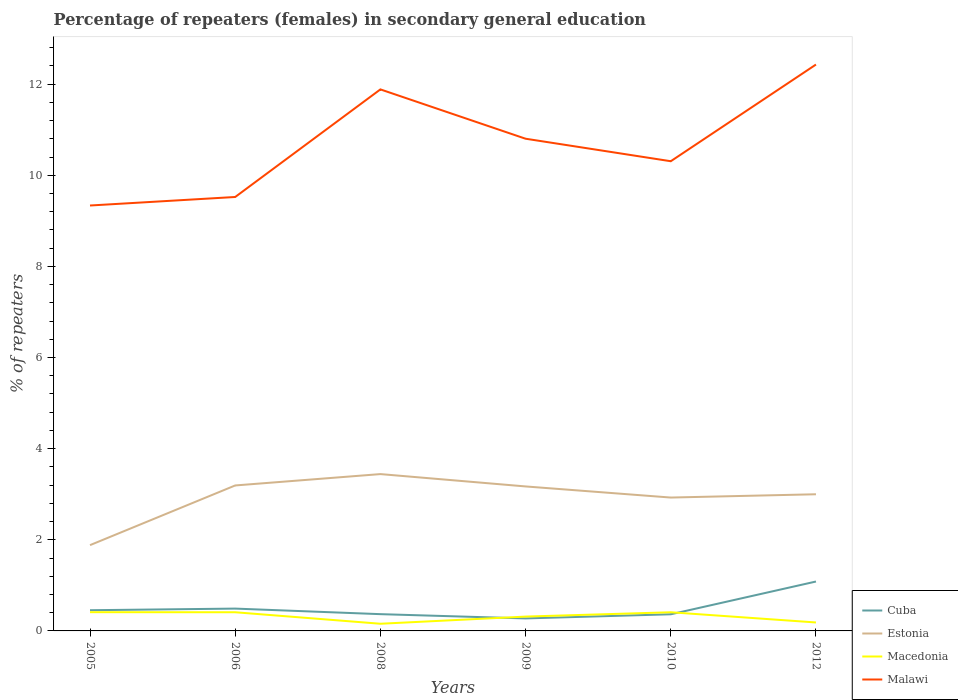Across all years, what is the maximum percentage of female repeaters in Cuba?
Keep it short and to the point. 0.27. What is the total percentage of female repeaters in Malawi in the graph?
Your answer should be very brief. -0.97. What is the difference between the highest and the second highest percentage of female repeaters in Malawi?
Your answer should be compact. 3.09. How many lines are there?
Offer a terse response. 4. Does the graph contain any zero values?
Give a very brief answer. No. Does the graph contain grids?
Offer a terse response. No. Where does the legend appear in the graph?
Give a very brief answer. Bottom right. How are the legend labels stacked?
Keep it short and to the point. Vertical. What is the title of the graph?
Your response must be concise. Percentage of repeaters (females) in secondary general education. What is the label or title of the X-axis?
Make the answer very short. Years. What is the label or title of the Y-axis?
Provide a succinct answer. % of repeaters. What is the % of repeaters in Cuba in 2005?
Offer a very short reply. 0.45. What is the % of repeaters of Estonia in 2005?
Provide a short and direct response. 1.88. What is the % of repeaters of Macedonia in 2005?
Provide a succinct answer. 0.41. What is the % of repeaters of Malawi in 2005?
Offer a very short reply. 9.34. What is the % of repeaters of Cuba in 2006?
Make the answer very short. 0.49. What is the % of repeaters of Estonia in 2006?
Your answer should be compact. 3.19. What is the % of repeaters of Macedonia in 2006?
Make the answer very short. 0.41. What is the % of repeaters in Malawi in 2006?
Offer a very short reply. 9.52. What is the % of repeaters in Cuba in 2008?
Keep it short and to the point. 0.37. What is the % of repeaters of Estonia in 2008?
Your response must be concise. 3.44. What is the % of repeaters of Macedonia in 2008?
Provide a short and direct response. 0.16. What is the % of repeaters of Malawi in 2008?
Your answer should be very brief. 11.88. What is the % of repeaters of Cuba in 2009?
Provide a succinct answer. 0.27. What is the % of repeaters in Estonia in 2009?
Keep it short and to the point. 3.17. What is the % of repeaters in Macedonia in 2009?
Your answer should be very brief. 0.31. What is the % of repeaters of Malawi in 2009?
Provide a short and direct response. 10.8. What is the % of repeaters in Cuba in 2010?
Your answer should be very brief. 0.37. What is the % of repeaters of Estonia in 2010?
Offer a very short reply. 2.93. What is the % of repeaters in Macedonia in 2010?
Keep it short and to the point. 0.41. What is the % of repeaters in Malawi in 2010?
Give a very brief answer. 10.31. What is the % of repeaters of Cuba in 2012?
Offer a very short reply. 1.08. What is the % of repeaters of Estonia in 2012?
Provide a succinct answer. 3. What is the % of repeaters of Macedonia in 2012?
Your response must be concise. 0.19. What is the % of repeaters in Malawi in 2012?
Ensure brevity in your answer.  12.43. Across all years, what is the maximum % of repeaters of Cuba?
Your answer should be compact. 1.08. Across all years, what is the maximum % of repeaters of Estonia?
Your response must be concise. 3.44. Across all years, what is the maximum % of repeaters of Macedonia?
Your answer should be very brief. 0.41. Across all years, what is the maximum % of repeaters of Malawi?
Provide a succinct answer. 12.43. Across all years, what is the minimum % of repeaters of Cuba?
Your answer should be compact. 0.27. Across all years, what is the minimum % of repeaters in Estonia?
Ensure brevity in your answer.  1.88. Across all years, what is the minimum % of repeaters of Macedonia?
Offer a terse response. 0.16. Across all years, what is the minimum % of repeaters of Malawi?
Your answer should be very brief. 9.34. What is the total % of repeaters of Cuba in the graph?
Make the answer very short. 3.04. What is the total % of repeaters of Estonia in the graph?
Keep it short and to the point. 17.61. What is the total % of repeaters of Macedonia in the graph?
Your answer should be compact. 1.89. What is the total % of repeaters of Malawi in the graph?
Offer a terse response. 64.28. What is the difference between the % of repeaters of Cuba in 2005 and that in 2006?
Your answer should be compact. -0.04. What is the difference between the % of repeaters in Estonia in 2005 and that in 2006?
Your response must be concise. -1.31. What is the difference between the % of repeaters in Macedonia in 2005 and that in 2006?
Ensure brevity in your answer.  0. What is the difference between the % of repeaters of Malawi in 2005 and that in 2006?
Make the answer very short. -0.19. What is the difference between the % of repeaters in Cuba in 2005 and that in 2008?
Offer a terse response. 0.09. What is the difference between the % of repeaters in Estonia in 2005 and that in 2008?
Make the answer very short. -1.56. What is the difference between the % of repeaters of Macedonia in 2005 and that in 2008?
Give a very brief answer. 0.25. What is the difference between the % of repeaters in Malawi in 2005 and that in 2008?
Provide a short and direct response. -2.55. What is the difference between the % of repeaters in Cuba in 2005 and that in 2009?
Make the answer very short. 0.18. What is the difference between the % of repeaters of Estonia in 2005 and that in 2009?
Your answer should be very brief. -1.29. What is the difference between the % of repeaters of Macedonia in 2005 and that in 2009?
Make the answer very short. 0.1. What is the difference between the % of repeaters of Malawi in 2005 and that in 2009?
Your answer should be very brief. -1.47. What is the difference between the % of repeaters in Cuba in 2005 and that in 2010?
Offer a very short reply. 0.09. What is the difference between the % of repeaters in Estonia in 2005 and that in 2010?
Your answer should be very brief. -1.04. What is the difference between the % of repeaters of Macedonia in 2005 and that in 2010?
Your answer should be very brief. 0. What is the difference between the % of repeaters in Malawi in 2005 and that in 2010?
Keep it short and to the point. -0.97. What is the difference between the % of repeaters of Cuba in 2005 and that in 2012?
Provide a short and direct response. -0.63. What is the difference between the % of repeaters of Estonia in 2005 and that in 2012?
Your answer should be compact. -1.12. What is the difference between the % of repeaters in Macedonia in 2005 and that in 2012?
Make the answer very short. 0.23. What is the difference between the % of repeaters of Malawi in 2005 and that in 2012?
Offer a very short reply. -3.09. What is the difference between the % of repeaters of Cuba in 2006 and that in 2008?
Offer a very short reply. 0.12. What is the difference between the % of repeaters in Estonia in 2006 and that in 2008?
Offer a terse response. -0.25. What is the difference between the % of repeaters in Macedonia in 2006 and that in 2008?
Offer a terse response. 0.25. What is the difference between the % of repeaters of Malawi in 2006 and that in 2008?
Ensure brevity in your answer.  -2.36. What is the difference between the % of repeaters of Cuba in 2006 and that in 2009?
Offer a terse response. 0.22. What is the difference between the % of repeaters of Estonia in 2006 and that in 2009?
Keep it short and to the point. 0.02. What is the difference between the % of repeaters in Macedonia in 2006 and that in 2009?
Offer a terse response. 0.1. What is the difference between the % of repeaters in Malawi in 2006 and that in 2009?
Ensure brevity in your answer.  -1.28. What is the difference between the % of repeaters of Cuba in 2006 and that in 2010?
Offer a terse response. 0.12. What is the difference between the % of repeaters in Estonia in 2006 and that in 2010?
Your answer should be very brief. 0.27. What is the difference between the % of repeaters of Malawi in 2006 and that in 2010?
Offer a very short reply. -0.78. What is the difference between the % of repeaters of Cuba in 2006 and that in 2012?
Give a very brief answer. -0.59. What is the difference between the % of repeaters in Estonia in 2006 and that in 2012?
Keep it short and to the point. 0.19. What is the difference between the % of repeaters of Macedonia in 2006 and that in 2012?
Provide a succinct answer. 0.22. What is the difference between the % of repeaters in Malawi in 2006 and that in 2012?
Your answer should be compact. -2.91. What is the difference between the % of repeaters in Cuba in 2008 and that in 2009?
Offer a very short reply. 0.09. What is the difference between the % of repeaters in Estonia in 2008 and that in 2009?
Your response must be concise. 0.27. What is the difference between the % of repeaters in Macedonia in 2008 and that in 2009?
Offer a terse response. -0.16. What is the difference between the % of repeaters in Malawi in 2008 and that in 2009?
Keep it short and to the point. 1.08. What is the difference between the % of repeaters in Cuba in 2008 and that in 2010?
Provide a short and direct response. 0. What is the difference between the % of repeaters of Estonia in 2008 and that in 2010?
Your response must be concise. 0.51. What is the difference between the % of repeaters of Macedonia in 2008 and that in 2010?
Your response must be concise. -0.25. What is the difference between the % of repeaters of Malawi in 2008 and that in 2010?
Give a very brief answer. 1.58. What is the difference between the % of repeaters of Cuba in 2008 and that in 2012?
Your answer should be very brief. -0.72. What is the difference between the % of repeaters in Estonia in 2008 and that in 2012?
Offer a very short reply. 0.44. What is the difference between the % of repeaters of Macedonia in 2008 and that in 2012?
Provide a short and direct response. -0.03. What is the difference between the % of repeaters in Malawi in 2008 and that in 2012?
Ensure brevity in your answer.  -0.55. What is the difference between the % of repeaters of Cuba in 2009 and that in 2010?
Your answer should be compact. -0.09. What is the difference between the % of repeaters of Estonia in 2009 and that in 2010?
Provide a succinct answer. 0.24. What is the difference between the % of repeaters in Macedonia in 2009 and that in 2010?
Your answer should be compact. -0.1. What is the difference between the % of repeaters of Malawi in 2009 and that in 2010?
Ensure brevity in your answer.  0.49. What is the difference between the % of repeaters of Cuba in 2009 and that in 2012?
Offer a terse response. -0.81. What is the difference between the % of repeaters of Estonia in 2009 and that in 2012?
Provide a short and direct response. 0.17. What is the difference between the % of repeaters in Macedonia in 2009 and that in 2012?
Your answer should be very brief. 0.13. What is the difference between the % of repeaters in Malawi in 2009 and that in 2012?
Give a very brief answer. -1.63. What is the difference between the % of repeaters of Cuba in 2010 and that in 2012?
Give a very brief answer. -0.72. What is the difference between the % of repeaters in Estonia in 2010 and that in 2012?
Provide a short and direct response. -0.07. What is the difference between the % of repeaters of Macedonia in 2010 and that in 2012?
Provide a short and direct response. 0.22. What is the difference between the % of repeaters of Malawi in 2010 and that in 2012?
Offer a very short reply. -2.12. What is the difference between the % of repeaters of Cuba in 2005 and the % of repeaters of Estonia in 2006?
Ensure brevity in your answer.  -2.74. What is the difference between the % of repeaters of Cuba in 2005 and the % of repeaters of Macedonia in 2006?
Offer a very short reply. 0.04. What is the difference between the % of repeaters in Cuba in 2005 and the % of repeaters in Malawi in 2006?
Keep it short and to the point. -9.07. What is the difference between the % of repeaters of Estonia in 2005 and the % of repeaters of Macedonia in 2006?
Provide a succinct answer. 1.47. What is the difference between the % of repeaters of Estonia in 2005 and the % of repeaters of Malawi in 2006?
Make the answer very short. -7.64. What is the difference between the % of repeaters of Macedonia in 2005 and the % of repeaters of Malawi in 2006?
Keep it short and to the point. -9.11. What is the difference between the % of repeaters of Cuba in 2005 and the % of repeaters of Estonia in 2008?
Your answer should be compact. -2.99. What is the difference between the % of repeaters in Cuba in 2005 and the % of repeaters in Macedonia in 2008?
Offer a very short reply. 0.3. What is the difference between the % of repeaters of Cuba in 2005 and the % of repeaters of Malawi in 2008?
Your response must be concise. -11.43. What is the difference between the % of repeaters of Estonia in 2005 and the % of repeaters of Macedonia in 2008?
Make the answer very short. 1.73. What is the difference between the % of repeaters in Estonia in 2005 and the % of repeaters in Malawi in 2008?
Make the answer very short. -10. What is the difference between the % of repeaters in Macedonia in 2005 and the % of repeaters in Malawi in 2008?
Your response must be concise. -11.47. What is the difference between the % of repeaters of Cuba in 2005 and the % of repeaters of Estonia in 2009?
Provide a short and direct response. -2.72. What is the difference between the % of repeaters in Cuba in 2005 and the % of repeaters in Macedonia in 2009?
Offer a very short reply. 0.14. What is the difference between the % of repeaters of Cuba in 2005 and the % of repeaters of Malawi in 2009?
Keep it short and to the point. -10.35. What is the difference between the % of repeaters of Estonia in 2005 and the % of repeaters of Macedonia in 2009?
Provide a short and direct response. 1.57. What is the difference between the % of repeaters of Estonia in 2005 and the % of repeaters of Malawi in 2009?
Offer a very short reply. -8.92. What is the difference between the % of repeaters in Macedonia in 2005 and the % of repeaters in Malawi in 2009?
Offer a terse response. -10.39. What is the difference between the % of repeaters in Cuba in 2005 and the % of repeaters in Estonia in 2010?
Offer a terse response. -2.47. What is the difference between the % of repeaters in Cuba in 2005 and the % of repeaters in Macedonia in 2010?
Give a very brief answer. 0.04. What is the difference between the % of repeaters of Cuba in 2005 and the % of repeaters of Malawi in 2010?
Provide a succinct answer. -9.85. What is the difference between the % of repeaters of Estonia in 2005 and the % of repeaters of Macedonia in 2010?
Your answer should be compact. 1.47. What is the difference between the % of repeaters of Estonia in 2005 and the % of repeaters of Malawi in 2010?
Provide a short and direct response. -8.43. What is the difference between the % of repeaters of Macedonia in 2005 and the % of repeaters of Malawi in 2010?
Provide a short and direct response. -9.9. What is the difference between the % of repeaters in Cuba in 2005 and the % of repeaters in Estonia in 2012?
Your answer should be very brief. -2.54. What is the difference between the % of repeaters of Cuba in 2005 and the % of repeaters of Macedonia in 2012?
Give a very brief answer. 0.27. What is the difference between the % of repeaters of Cuba in 2005 and the % of repeaters of Malawi in 2012?
Make the answer very short. -11.98. What is the difference between the % of repeaters in Estonia in 2005 and the % of repeaters in Macedonia in 2012?
Keep it short and to the point. 1.7. What is the difference between the % of repeaters of Estonia in 2005 and the % of repeaters of Malawi in 2012?
Ensure brevity in your answer.  -10.55. What is the difference between the % of repeaters in Macedonia in 2005 and the % of repeaters in Malawi in 2012?
Your answer should be compact. -12.02. What is the difference between the % of repeaters in Cuba in 2006 and the % of repeaters in Estonia in 2008?
Offer a terse response. -2.95. What is the difference between the % of repeaters in Cuba in 2006 and the % of repeaters in Macedonia in 2008?
Provide a short and direct response. 0.33. What is the difference between the % of repeaters of Cuba in 2006 and the % of repeaters of Malawi in 2008?
Offer a very short reply. -11.39. What is the difference between the % of repeaters in Estonia in 2006 and the % of repeaters in Macedonia in 2008?
Provide a succinct answer. 3.04. What is the difference between the % of repeaters in Estonia in 2006 and the % of repeaters in Malawi in 2008?
Provide a succinct answer. -8.69. What is the difference between the % of repeaters in Macedonia in 2006 and the % of repeaters in Malawi in 2008?
Provide a short and direct response. -11.47. What is the difference between the % of repeaters of Cuba in 2006 and the % of repeaters of Estonia in 2009?
Your response must be concise. -2.68. What is the difference between the % of repeaters in Cuba in 2006 and the % of repeaters in Macedonia in 2009?
Your answer should be very brief. 0.18. What is the difference between the % of repeaters in Cuba in 2006 and the % of repeaters in Malawi in 2009?
Offer a terse response. -10.31. What is the difference between the % of repeaters of Estonia in 2006 and the % of repeaters of Macedonia in 2009?
Keep it short and to the point. 2.88. What is the difference between the % of repeaters in Estonia in 2006 and the % of repeaters in Malawi in 2009?
Your answer should be very brief. -7.61. What is the difference between the % of repeaters of Macedonia in 2006 and the % of repeaters of Malawi in 2009?
Offer a very short reply. -10.39. What is the difference between the % of repeaters of Cuba in 2006 and the % of repeaters of Estonia in 2010?
Your response must be concise. -2.44. What is the difference between the % of repeaters in Cuba in 2006 and the % of repeaters in Macedonia in 2010?
Offer a very short reply. 0.08. What is the difference between the % of repeaters of Cuba in 2006 and the % of repeaters of Malawi in 2010?
Make the answer very short. -9.82. What is the difference between the % of repeaters of Estonia in 2006 and the % of repeaters of Macedonia in 2010?
Your answer should be compact. 2.78. What is the difference between the % of repeaters in Estonia in 2006 and the % of repeaters in Malawi in 2010?
Offer a terse response. -7.12. What is the difference between the % of repeaters of Macedonia in 2006 and the % of repeaters of Malawi in 2010?
Your answer should be compact. -9.9. What is the difference between the % of repeaters in Cuba in 2006 and the % of repeaters in Estonia in 2012?
Your answer should be compact. -2.51. What is the difference between the % of repeaters in Cuba in 2006 and the % of repeaters in Macedonia in 2012?
Give a very brief answer. 0.3. What is the difference between the % of repeaters in Cuba in 2006 and the % of repeaters in Malawi in 2012?
Your response must be concise. -11.94. What is the difference between the % of repeaters of Estonia in 2006 and the % of repeaters of Macedonia in 2012?
Give a very brief answer. 3.01. What is the difference between the % of repeaters of Estonia in 2006 and the % of repeaters of Malawi in 2012?
Provide a succinct answer. -9.24. What is the difference between the % of repeaters of Macedonia in 2006 and the % of repeaters of Malawi in 2012?
Your answer should be compact. -12.02. What is the difference between the % of repeaters in Cuba in 2008 and the % of repeaters in Estonia in 2009?
Make the answer very short. -2.8. What is the difference between the % of repeaters of Cuba in 2008 and the % of repeaters of Macedonia in 2009?
Offer a very short reply. 0.05. What is the difference between the % of repeaters in Cuba in 2008 and the % of repeaters in Malawi in 2009?
Offer a very short reply. -10.43. What is the difference between the % of repeaters in Estonia in 2008 and the % of repeaters in Macedonia in 2009?
Make the answer very short. 3.13. What is the difference between the % of repeaters in Estonia in 2008 and the % of repeaters in Malawi in 2009?
Make the answer very short. -7.36. What is the difference between the % of repeaters in Macedonia in 2008 and the % of repeaters in Malawi in 2009?
Offer a terse response. -10.64. What is the difference between the % of repeaters in Cuba in 2008 and the % of repeaters in Estonia in 2010?
Your response must be concise. -2.56. What is the difference between the % of repeaters in Cuba in 2008 and the % of repeaters in Macedonia in 2010?
Your answer should be compact. -0.04. What is the difference between the % of repeaters of Cuba in 2008 and the % of repeaters of Malawi in 2010?
Offer a very short reply. -9.94. What is the difference between the % of repeaters of Estonia in 2008 and the % of repeaters of Macedonia in 2010?
Provide a short and direct response. 3.03. What is the difference between the % of repeaters of Estonia in 2008 and the % of repeaters of Malawi in 2010?
Your response must be concise. -6.87. What is the difference between the % of repeaters of Macedonia in 2008 and the % of repeaters of Malawi in 2010?
Provide a succinct answer. -10.15. What is the difference between the % of repeaters in Cuba in 2008 and the % of repeaters in Estonia in 2012?
Keep it short and to the point. -2.63. What is the difference between the % of repeaters in Cuba in 2008 and the % of repeaters in Macedonia in 2012?
Offer a terse response. 0.18. What is the difference between the % of repeaters of Cuba in 2008 and the % of repeaters of Malawi in 2012?
Give a very brief answer. -12.06. What is the difference between the % of repeaters in Estonia in 2008 and the % of repeaters in Macedonia in 2012?
Provide a short and direct response. 3.26. What is the difference between the % of repeaters of Estonia in 2008 and the % of repeaters of Malawi in 2012?
Keep it short and to the point. -8.99. What is the difference between the % of repeaters of Macedonia in 2008 and the % of repeaters of Malawi in 2012?
Make the answer very short. -12.27. What is the difference between the % of repeaters in Cuba in 2009 and the % of repeaters in Estonia in 2010?
Your response must be concise. -2.65. What is the difference between the % of repeaters of Cuba in 2009 and the % of repeaters of Macedonia in 2010?
Offer a terse response. -0.14. What is the difference between the % of repeaters in Cuba in 2009 and the % of repeaters in Malawi in 2010?
Provide a succinct answer. -10.03. What is the difference between the % of repeaters in Estonia in 2009 and the % of repeaters in Macedonia in 2010?
Your answer should be very brief. 2.76. What is the difference between the % of repeaters of Estonia in 2009 and the % of repeaters of Malawi in 2010?
Provide a succinct answer. -7.14. What is the difference between the % of repeaters of Macedonia in 2009 and the % of repeaters of Malawi in 2010?
Your answer should be compact. -9.99. What is the difference between the % of repeaters in Cuba in 2009 and the % of repeaters in Estonia in 2012?
Keep it short and to the point. -2.72. What is the difference between the % of repeaters in Cuba in 2009 and the % of repeaters in Macedonia in 2012?
Your response must be concise. 0.09. What is the difference between the % of repeaters of Cuba in 2009 and the % of repeaters of Malawi in 2012?
Ensure brevity in your answer.  -12.16. What is the difference between the % of repeaters of Estonia in 2009 and the % of repeaters of Macedonia in 2012?
Your response must be concise. 2.99. What is the difference between the % of repeaters of Estonia in 2009 and the % of repeaters of Malawi in 2012?
Your answer should be compact. -9.26. What is the difference between the % of repeaters of Macedonia in 2009 and the % of repeaters of Malawi in 2012?
Provide a succinct answer. -12.12. What is the difference between the % of repeaters of Cuba in 2010 and the % of repeaters of Estonia in 2012?
Offer a very short reply. -2.63. What is the difference between the % of repeaters of Cuba in 2010 and the % of repeaters of Macedonia in 2012?
Ensure brevity in your answer.  0.18. What is the difference between the % of repeaters of Cuba in 2010 and the % of repeaters of Malawi in 2012?
Give a very brief answer. -12.06. What is the difference between the % of repeaters in Estonia in 2010 and the % of repeaters in Macedonia in 2012?
Provide a succinct answer. 2.74. What is the difference between the % of repeaters in Estonia in 2010 and the % of repeaters in Malawi in 2012?
Provide a short and direct response. -9.5. What is the difference between the % of repeaters of Macedonia in 2010 and the % of repeaters of Malawi in 2012?
Your response must be concise. -12.02. What is the average % of repeaters in Cuba per year?
Make the answer very short. 0.51. What is the average % of repeaters of Estonia per year?
Make the answer very short. 2.94. What is the average % of repeaters in Macedonia per year?
Give a very brief answer. 0.31. What is the average % of repeaters of Malawi per year?
Your answer should be very brief. 10.71. In the year 2005, what is the difference between the % of repeaters in Cuba and % of repeaters in Estonia?
Your answer should be compact. -1.43. In the year 2005, what is the difference between the % of repeaters in Cuba and % of repeaters in Macedonia?
Offer a terse response. 0.04. In the year 2005, what is the difference between the % of repeaters in Cuba and % of repeaters in Malawi?
Your answer should be compact. -8.88. In the year 2005, what is the difference between the % of repeaters of Estonia and % of repeaters of Macedonia?
Keep it short and to the point. 1.47. In the year 2005, what is the difference between the % of repeaters in Estonia and % of repeaters in Malawi?
Your answer should be compact. -7.45. In the year 2005, what is the difference between the % of repeaters in Macedonia and % of repeaters in Malawi?
Ensure brevity in your answer.  -8.93. In the year 2006, what is the difference between the % of repeaters of Cuba and % of repeaters of Estonia?
Your answer should be very brief. -2.7. In the year 2006, what is the difference between the % of repeaters of Cuba and % of repeaters of Macedonia?
Provide a short and direct response. 0.08. In the year 2006, what is the difference between the % of repeaters of Cuba and % of repeaters of Malawi?
Ensure brevity in your answer.  -9.03. In the year 2006, what is the difference between the % of repeaters in Estonia and % of repeaters in Macedonia?
Your response must be concise. 2.78. In the year 2006, what is the difference between the % of repeaters in Estonia and % of repeaters in Malawi?
Provide a succinct answer. -6.33. In the year 2006, what is the difference between the % of repeaters in Macedonia and % of repeaters in Malawi?
Your answer should be very brief. -9.11. In the year 2008, what is the difference between the % of repeaters of Cuba and % of repeaters of Estonia?
Your response must be concise. -3.07. In the year 2008, what is the difference between the % of repeaters of Cuba and % of repeaters of Macedonia?
Ensure brevity in your answer.  0.21. In the year 2008, what is the difference between the % of repeaters in Cuba and % of repeaters in Malawi?
Make the answer very short. -11.52. In the year 2008, what is the difference between the % of repeaters in Estonia and % of repeaters in Macedonia?
Keep it short and to the point. 3.28. In the year 2008, what is the difference between the % of repeaters in Estonia and % of repeaters in Malawi?
Offer a terse response. -8.44. In the year 2008, what is the difference between the % of repeaters of Macedonia and % of repeaters of Malawi?
Give a very brief answer. -11.73. In the year 2009, what is the difference between the % of repeaters in Cuba and % of repeaters in Estonia?
Offer a very short reply. -2.9. In the year 2009, what is the difference between the % of repeaters of Cuba and % of repeaters of Macedonia?
Your answer should be compact. -0.04. In the year 2009, what is the difference between the % of repeaters in Cuba and % of repeaters in Malawi?
Give a very brief answer. -10.53. In the year 2009, what is the difference between the % of repeaters of Estonia and % of repeaters of Macedonia?
Your response must be concise. 2.86. In the year 2009, what is the difference between the % of repeaters in Estonia and % of repeaters in Malawi?
Ensure brevity in your answer.  -7.63. In the year 2009, what is the difference between the % of repeaters in Macedonia and % of repeaters in Malawi?
Your answer should be very brief. -10.49. In the year 2010, what is the difference between the % of repeaters of Cuba and % of repeaters of Estonia?
Provide a succinct answer. -2.56. In the year 2010, what is the difference between the % of repeaters of Cuba and % of repeaters of Macedonia?
Give a very brief answer. -0.04. In the year 2010, what is the difference between the % of repeaters of Cuba and % of repeaters of Malawi?
Your answer should be very brief. -9.94. In the year 2010, what is the difference between the % of repeaters in Estonia and % of repeaters in Macedonia?
Offer a very short reply. 2.52. In the year 2010, what is the difference between the % of repeaters in Estonia and % of repeaters in Malawi?
Provide a succinct answer. -7.38. In the year 2010, what is the difference between the % of repeaters in Macedonia and % of repeaters in Malawi?
Your response must be concise. -9.9. In the year 2012, what is the difference between the % of repeaters of Cuba and % of repeaters of Estonia?
Keep it short and to the point. -1.92. In the year 2012, what is the difference between the % of repeaters in Cuba and % of repeaters in Macedonia?
Your answer should be very brief. 0.9. In the year 2012, what is the difference between the % of repeaters of Cuba and % of repeaters of Malawi?
Provide a succinct answer. -11.35. In the year 2012, what is the difference between the % of repeaters of Estonia and % of repeaters of Macedonia?
Offer a terse response. 2.81. In the year 2012, what is the difference between the % of repeaters of Estonia and % of repeaters of Malawi?
Provide a succinct answer. -9.43. In the year 2012, what is the difference between the % of repeaters of Macedonia and % of repeaters of Malawi?
Your response must be concise. -12.24. What is the ratio of the % of repeaters of Cuba in 2005 to that in 2006?
Ensure brevity in your answer.  0.93. What is the ratio of the % of repeaters of Estonia in 2005 to that in 2006?
Make the answer very short. 0.59. What is the ratio of the % of repeaters of Macedonia in 2005 to that in 2006?
Offer a terse response. 1. What is the ratio of the % of repeaters of Malawi in 2005 to that in 2006?
Your answer should be compact. 0.98. What is the ratio of the % of repeaters of Cuba in 2005 to that in 2008?
Your answer should be very brief. 1.24. What is the ratio of the % of repeaters of Estonia in 2005 to that in 2008?
Offer a very short reply. 0.55. What is the ratio of the % of repeaters in Macedonia in 2005 to that in 2008?
Ensure brevity in your answer.  2.61. What is the ratio of the % of repeaters of Malawi in 2005 to that in 2008?
Provide a short and direct response. 0.79. What is the ratio of the % of repeaters of Cuba in 2005 to that in 2009?
Give a very brief answer. 1.66. What is the ratio of the % of repeaters of Estonia in 2005 to that in 2009?
Offer a terse response. 0.59. What is the ratio of the % of repeaters in Macedonia in 2005 to that in 2009?
Ensure brevity in your answer.  1.31. What is the ratio of the % of repeaters of Malawi in 2005 to that in 2009?
Provide a short and direct response. 0.86. What is the ratio of the % of repeaters of Cuba in 2005 to that in 2010?
Provide a succinct answer. 1.24. What is the ratio of the % of repeaters in Estonia in 2005 to that in 2010?
Provide a succinct answer. 0.64. What is the ratio of the % of repeaters in Macedonia in 2005 to that in 2010?
Give a very brief answer. 1. What is the ratio of the % of repeaters of Malawi in 2005 to that in 2010?
Make the answer very short. 0.91. What is the ratio of the % of repeaters of Cuba in 2005 to that in 2012?
Ensure brevity in your answer.  0.42. What is the ratio of the % of repeaters in Estonia in 2005 to that in 2012?
Give a very brief answer. 0.63. What is the ratio of the % of repeaters of Macedonia in 2005 to that in 2012?
Give a very brief answer. 2.22. What is the ratio of the % of repeaters of Malawi in 2005 to that in 2012?
Offer a very short reply. 0.75. What is the ratio of the % of repeaters of Cuba in 2006 to that in 2008?
Keep it short and to the point. 1.33. What is the ratio of the % of repeaters of Estonia in 2006 to that in 2008?
Offer a very short reply. 0.93. What is the ratio of the % of repeaters of Macedonia in 2006 to that in 2008?
Make the answer very short. 2.6. What is the ratio of the % of repeaters of Malawi in 2006 to that in 2008?
Offer a very short reply. 0.8. What is the ratio of the % of repeaters in Cuba in 2006 to that in 2009?
Your response must be concise. 1.79. What is the ratio of the % of repeaters in Estonia in 2006 to that in 2009?
Make the answer very short. 1.01. What is the ratio of the % of repeaters in Macedonia in 2006 to that in 2009?
Your response must be concise. 1.3. What is the ratio of the % of repeaters of Malawi in 2006 to that in 2009?
Keep it short and to the point. 0.88. What is the ratio of the % of repeaters in Cuba in 2006 to that in 2010?
Offer a very short reply. 1.34. What is the ratio of the % of repeaters in Estonia in 2006 to that in 2010?
Offer a terse response. 1.09. What is the ratio of the % of repeaters of Malawi in 2006 to that in 2010?
Keep it short and to the point. 0.92. What is the ratio of the % of repeaters of Cuba in 2006 to that in 2012?
Offer a very short reply. 0.45. What is the ratio of the % of repeaters of Estonia in 2006 to that in 2012?
Make the answer very short. 1.06. What is the ratio of the % of repeaters of Macedonia in 2006 to that in 2012?
Provide a succinct answer. 2.21. What is the ratio of the % of repeaters of Malawi in 2006 to that in 2012?
Provide a succinct answer. 0.77. What is the ratio of the % of repeaters of Cuba in 2008 to that in 2009?
Keep it short and to the point. 1.34. What is the ratio of the % of repeaters of Estonia in 2008 to that in 2009?
Your response must be concise. 1.09. What is the ratio of the % of repeaters in Macedonia in 2008 to that in 2009?
Provide a short and direct response. 0.5. What is the ratio of the % of repeaters of Malawi in 2008 to that in 2009?
Provide a short and direct response. 1.1. What is the ratio of the % of repeaters in Cuba in 2008 to that in 2010?
Make the answer very short. 1.01. What is the ratio of the % of repeaters in Estonia in 2008 to that in 2010?
Provide a short and direct response. 1.18. What is the ratio of the % of repeaters of Macedonia in 2008 to that in 2010?
Give a very brief answer. 0.38. What is the ratio of the % of repeaters of Malawi in 2008 to that in 2010?
Offer a terse response. 1.15. What is the ratio of the % of repeaters of Cuba in 2008 to that in 2012?
Provide a short and direct response. 0.34. What is the ratio of the % of repeaters in Estonia in 2008 to that in 2012?
Keep it short and to the point. 1.15. What is the ratio of the % of repeaters of Macedonia in 2008 to that in 2012?
Offer a terse response. 0.85. What is the ratio of the % of repeaters in Malawi in 2008 to that in 2012?
Your answer should be very brief. 0.96. What is the ratio of the % of repeaters of Cuba in 2009 to that in 2010?
Offer a very short reply. 0.75. What is the ratio of the % of repeaters in Estonia in 2009 to that in 2010?
Your response must be concise. 1.08. What is the ratio of the % of repeaters in Macedonia in 2009 to that in 2010?
Provide a succinct answer. 0.77. What is the ratio of the % of repeaters of Malawi in 2009 to that in 2010?
Keep it short and to the point. 1.05. What is the ratio of the % of repeaters in Cuba in 2009 to that in 2012?
Make the answer very short. 0.25. What is the ratio of the % of repeaters in Estonia in 2009 to that in 2012?
Offer a very short reply. 1.06. What is the ratio of the % of repeaters of Macedonia in 2009 to that in 2012?
Keep it short and to the point. 1.7. What is the ratio of the % of repeaters of Malawi in 2009 to that in 2012?
Your response must be concise. 0.87. What is the ratio of the % of repeaters in Cuba in 2010 to that in 2012?
Offer a terse response. 0.34. What is the ratio of the % of repeaters in Estonia in 2010 to that in 2012?
Give a very brief answer. 0.98. What is the ratio of the % of repeaters in Macedonia in 2010 to that in 2012?
Give a very brief answer. 2.21. What is the ratio of the % of repeaters in Malawi in 2010 to that in 2012?
Make the answer very short. 0.83. What is the difference between the highest and the second highest % of repeaters in Cuba?
Make the answer very short. 0.59. What is the difference between the highest and the second highest % of repeaters in Estonia?
Keep it short and to the point. 0.25. What is the difference between the highest and the second highest % of repeaters in Macedonia?
Offer a terse response. 0. What is the difference between the highest and the second highest % of repeaters of Malawi?
Make the answer very short. 0.55. What is the difference between the highest and the lowest % of repeaters in Cuba?
Give a very brief answer. 0.81. What is the difference between the highest and the lowest % of repeaters in Estonia?
Your response must be concise. 1.56. What is the difference between the highest and the lowest % of repeaters of Macedonia?
Give a very brief answer. 0.25. What is the difference between the highest and the lowest % of repeaters in Malawi?
Keep it short and to the point. 3.09. 